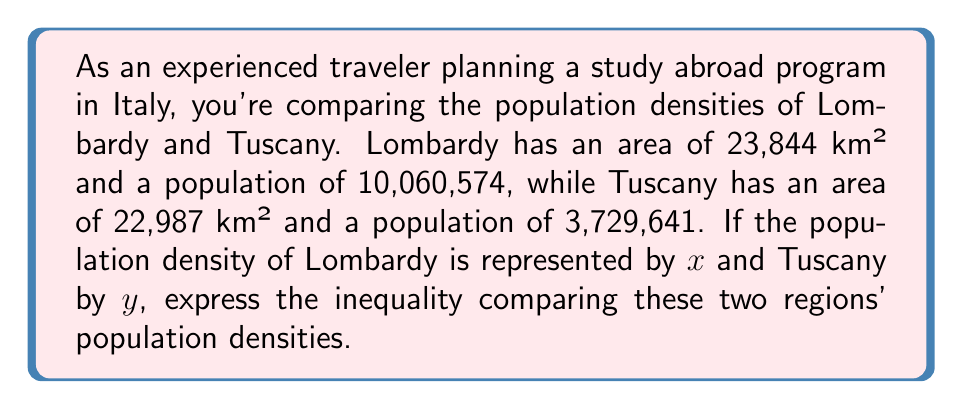Could you help me with this problem? 1. Calculate the population density for Lombardy:
   $x = \frac{10,060,574}{23,844} \approx 421.93$ people/km²

2. Calculate the population density for Tuscany:
   $y = \frac{3,729,641}{22,987} \approx 162.25$ people/km²

3. Compare the two densities:
   $421.93 > 162.25$

4. Express this comparison using the variables $x$ and $y$:
   $x > y$

This inequality shows that Lombardy has a higher population density than Tuscany, which is important to consider when planning immersive study abroad programs, as it may affect the cultural experience and available resources in each region.
Answer: $x > y$ 